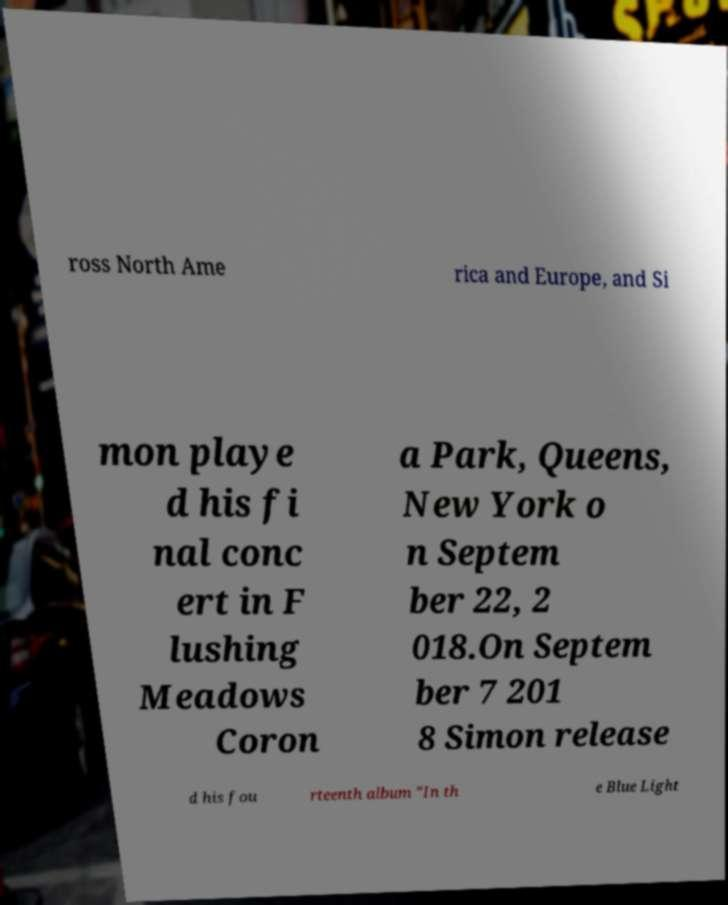Could you assist in decoding the text presented in this image and type it out clearly? ross North Ame rica and Europe, and Si mon playe d his fi nal conc ert in F lushing Meadows Coron a Park, Queens, New York o n Septem ber 22, 2 018.On Septem ber 7 201 8 Simon release d his fou rteenth album "In th e Blue Light 